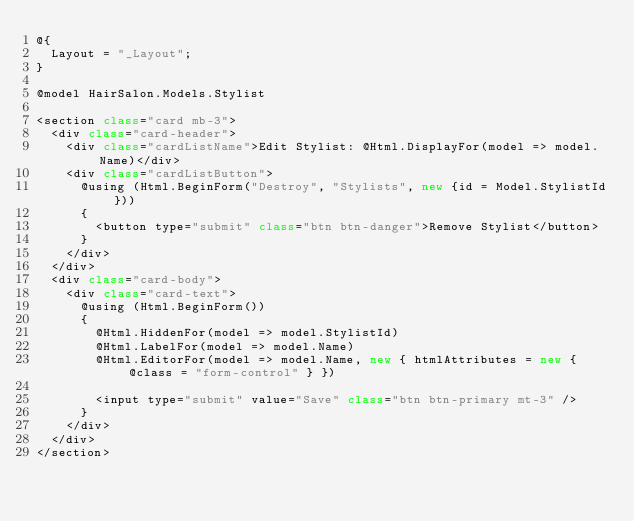Convert code to text. <code><loc_0><loc_0><loc_500><loc_500><_C#_>@{
  Layout = "_Layout";
}

@model HairSalon.Models.Stylist

<section class="card mb-3">
  <div class="card-header">
    <div class="cardListName">Edit Stylist: @Html.DisplayFor(model => model.Name)</div>
    <div class="cardListButton">
      @using (Html.BeginForm("Destroy", "Stylists", new {id = Model.StylistId}))
      {
        <button type="submit" class="btn btn-danger">Remove Stylist</button>
      }
    </div>
  </div>
  <div class="card-body">
    <div class="card-text">
      @using (Html.BeginForm())
      {
        @Html.HiddenFor(model => model.StylistId)
        @Html.LabelFor(model => model.Name)
        @Html.EditorFor(model => model.Name, new { htmlAttributes = new { @class = "form-control" } })

        <input type="submit" value="Save" class="btn btn-primary mt-3" />
      }
    </div>
  </div>
</section></code> 